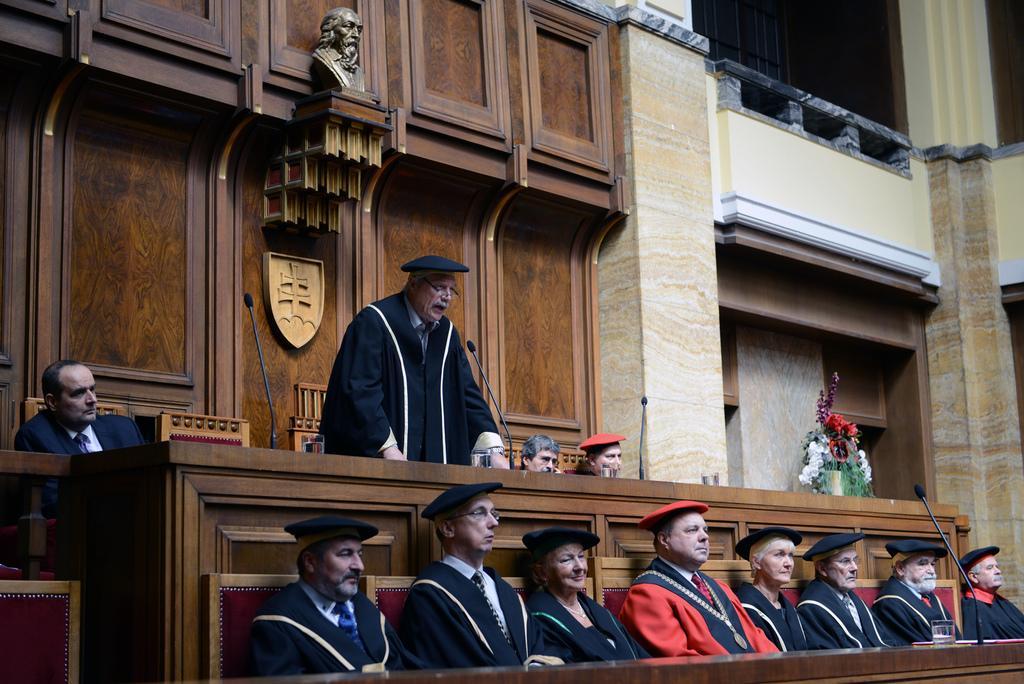Please provide a concise description of this image. In this picture there is a person standing and talking and there are group of people sitting and there are microphones and glasses and there is a flower vase on the table. At the back there is a sculpture on the wall. At the top right it looks like a railing. 